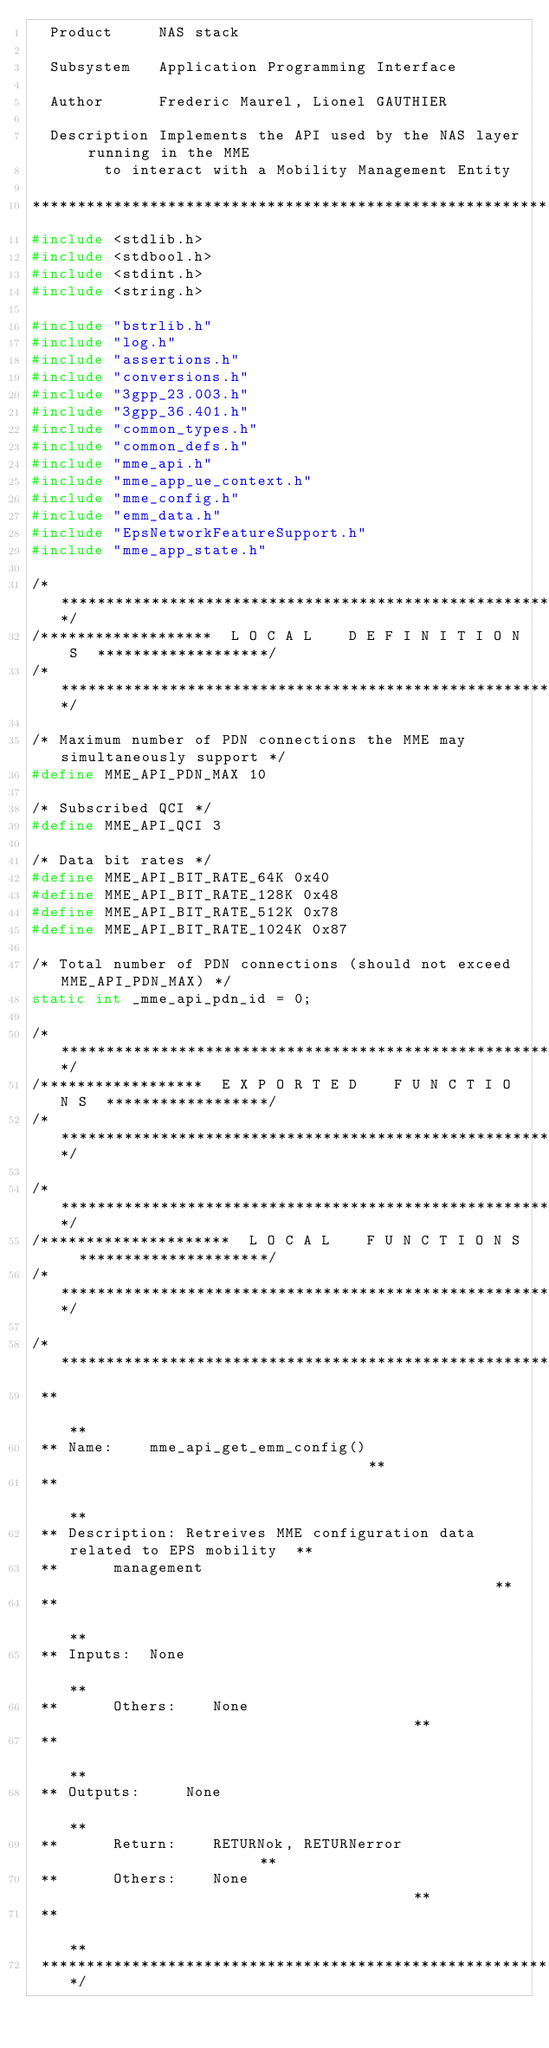<code> <loc_0><loc_0><loc_500><loc_500><_C_>  Product     NAS stack

  Subsystem   Application Programming Interface

  Author      Frederic Maurel, Lionel GAUTHIER

  Description Implements the API used by the NAS layer running in the MME
        to interact with a Mobility Management Entity

*****************************************************************************/
#include <stdlib.h>
#include <stdbool.h>
#include <stdint.h>
#include <string.h>

#include "bstrlib.h"
#include "log.h"
#include "assertions.h"
#include "conversions.h"
#include "3gpp_23.003.h"
#include "3gpp_36.401.h"
#include "common_types.h"
#include "common_defs.h"
#include "mme_api.h"
#include "mme_app_ue_context.h"
#include "mme_config.h"
#include "emm_data.h"
#include "EpsNetworkFeatureSupport.h"
#include "mme_app_state.h"

/****************************************************************************/
/*******************  L O C A L    D E F I N I T I O N S  *******************/
/****************************************************************************/

/* Maximum number of PDN connections the MME may simultaneously support */
#define MME_API_PDN_MAX 10

/* Subscribed QCI */
#define MME_API_QCI 3

/* Data bit rates */
#define MME_API_BIT_RATE_64K 0x40
#define MME_API_BIT_RATE_128K 0x48
#define MME_API_BIT_RATE_512K 0x78
#define MME_API_BIT_RATE_1024K 0x87

/* Total number of PDN connections (should not exceed MME_API_PDN_MAX) */
static int _mme_api_pdn_id = 0;

/****************************************************************************/
/******************  E X P O R T E D    F U N C T I O N S  ******************/
/****************************************************************************/

/****************************************************************************/
/*********************  L O C A L    F U N C T I O N S  *********************/
/****************************************************************************/

/****************************************************************************
 **                                                                        **
 ** Name:    mme_api_get_emm_config()                                  **
 **                                                                        **
 ** Description: Retreives MME configuration data related to EPS mobility  **
 **      management                                                **
 **                                                                        **
 ** Inputs:  None                                                      **
 **      Others:    None                                       **
 **                                                                        **
 ** Outputs:     None                                                      **
 **      Return:    RETURNok, RETURNerror                      **
 **      Others:    None                                       **
 **                                                                        **
 ***************************************************************************/</code> 